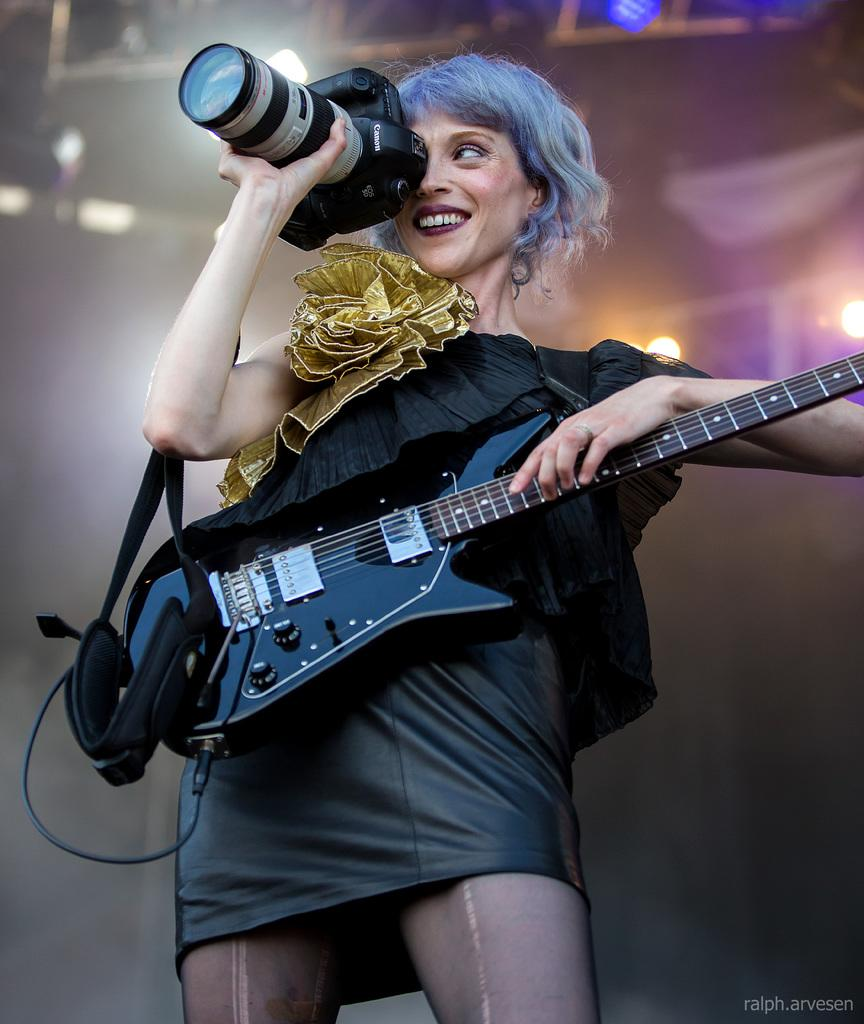Who is the main subject in the image? There is a woman in the image. What is the woman holding in the image? The woman is holding a guitar and a camera. Can you describe any other objects in the image? There is a light in the image. What verse is the woman reciting in the image? There is no indication in the image that the woman is reciting a verse. 